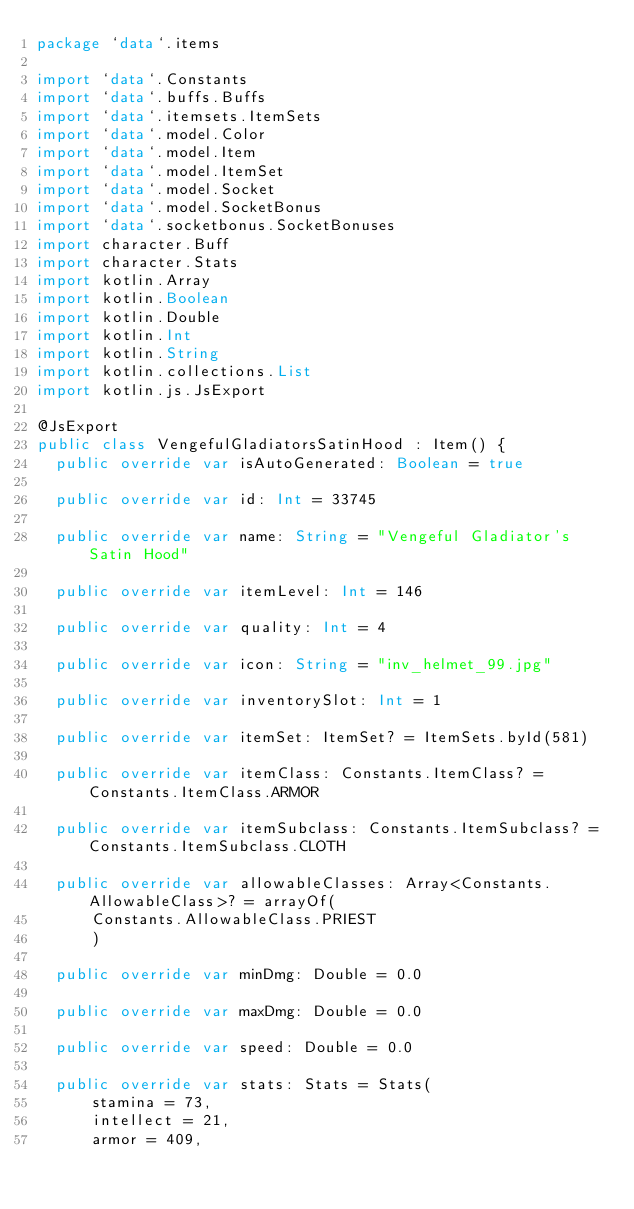<code> <loc_0><loc_0><loc_500><loc_500><_Kotlin_>package `data`.items

import `data`.Constants
import `data`.buffs.Buffs
import `data`.itemsets.ItemSets
import `data`.model.Color
import `data`.model.Item
import `data`.model.ItemSet
import `data`.model.Socket
import `data`.model.SocketBonus
import `data`.socketbonus.SocketBonuses
import character.Buff
import character.Stats
import kotlin.Array
import kotlin.Boolean
import kotlin.Double
import kotlin.Int
import kotlin.String
import kotlin.collections.List
import kotlin.js.JsExport

@JsExport
public class VengefulGladiatorsSatinHood : Item() {
  public override var isAutoGenerated: Boolean = true

  public override var id: Int = 33745

  public override var name: String = "Vengeful Gladiator's Satin Hood"

  public override var itemLevel: Int = 146

  public override var quality: Int = 4

  public override var icon: String = "inv_helmet_99.jpg"

  public override var inventorySlot: Int = 1

  public override var itemSet: ItemSet? = ItemSets.byId(581)

  public override var itemClass: Constants.ItemClass? = Constants.ItemClass.ARMOR

  public override var itemSubclass: Constants.ItemSubclass? = Constants.ItemSubclass.CLOTH

  public override var allowableClasses: Array<Constants.AllowableClass>? = arrayOf(
      Constants.AllowableClass.PRIEST
      )

  public override var minDmg: Double = 0.0

  public override var maxDmg: Double = 0.0

  public override var speed: Double = 0.0

  public override var stats: Stats = Stats(
      stamina = 73,
      intellect = 21,
      armor = 409,</code> 